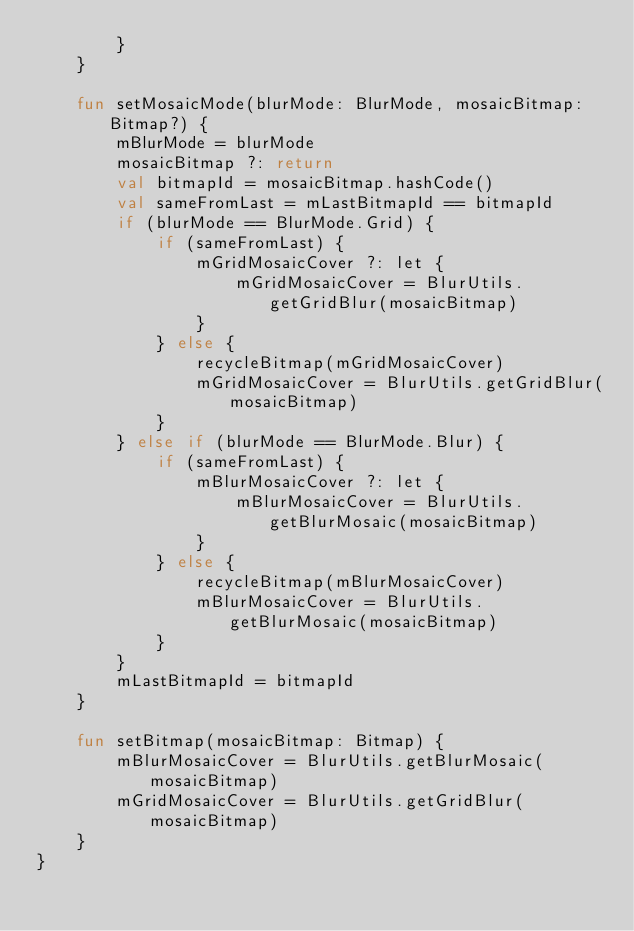<code> <loc_0><loc_0><loc_500><loc_500><_Kotlin_>        }
    }

    fun setMosaicMode(blurMode: BlurMode, mosaicBitmap: Bitmap?) {
        mBlurMode = blurMode
        mosaicBitmap ?: return
        val bitmapId = mosaicBitmap.hashCode()
        val sameFromLast = mLastBitmapId == bitmapId
        if (blurMode == BlurMode.Grid) {
            if (sameFromLast) {
                mGridMosaicCover ?: let {
                    mGridMosaicCover = BlurUtils.getGridBlur(mosaicBitmap)
                }
            } else {
                recycleBitmap(mGridMosaicCover)
                mGridMosaicCover = BlurUtils.getGridBlur(mosaicBitmap)
            }
        } else if (blurMode == BlurMode.Blur) {
            if (sameFromLast) {
                mBlurMosaicCover ?: let {
                    mBlurMosaicCover = BlurUtils.getBlurMosaic(mosaicBitmap)
                }
            } else {
                recycleBitmap(mBlurMosaicCover)
                mBlurMosaicCover = BlurUtils.getBlurMosaic(mosaicBitmap)
            }
        }
        mLastBitmapId = bitmapId
    }

    fun setBitmap(mosaicBitmap: Bitmap) {
        mBlurMosaicCover = BlurUtils.getBlurMosaic(mosaicBitmap)
        mGridMosaicCover = BlurUtils.getGridBlur(mosaicBitmap)
    }
}</code> 